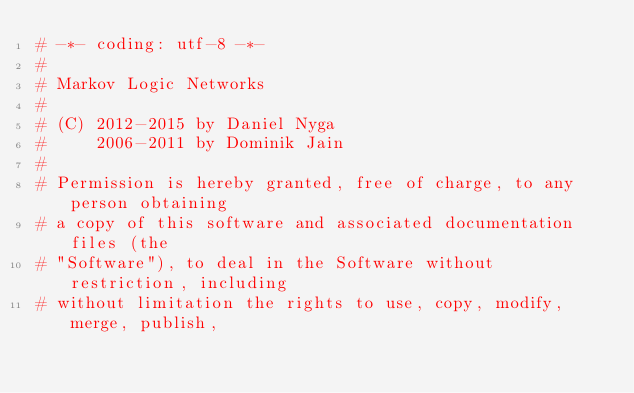<code> <loc_0><loc_0><loc_500><loc_500><_Cython_># -*- coding: utf-8 -*-
#
# Markov Logic Networks
#
# (C) 2012-2015 by Daniel Nyga
#     2006-2011 by Dominik Jain
#
# Permission is hereby granted, free of charge, to any person obtaining
# a copy of this software and associated documentation files (the
# "Software"), to deal in the Software without restriction, including
# without limitation the rights to use, copy, modify, merge, publish,</code> 